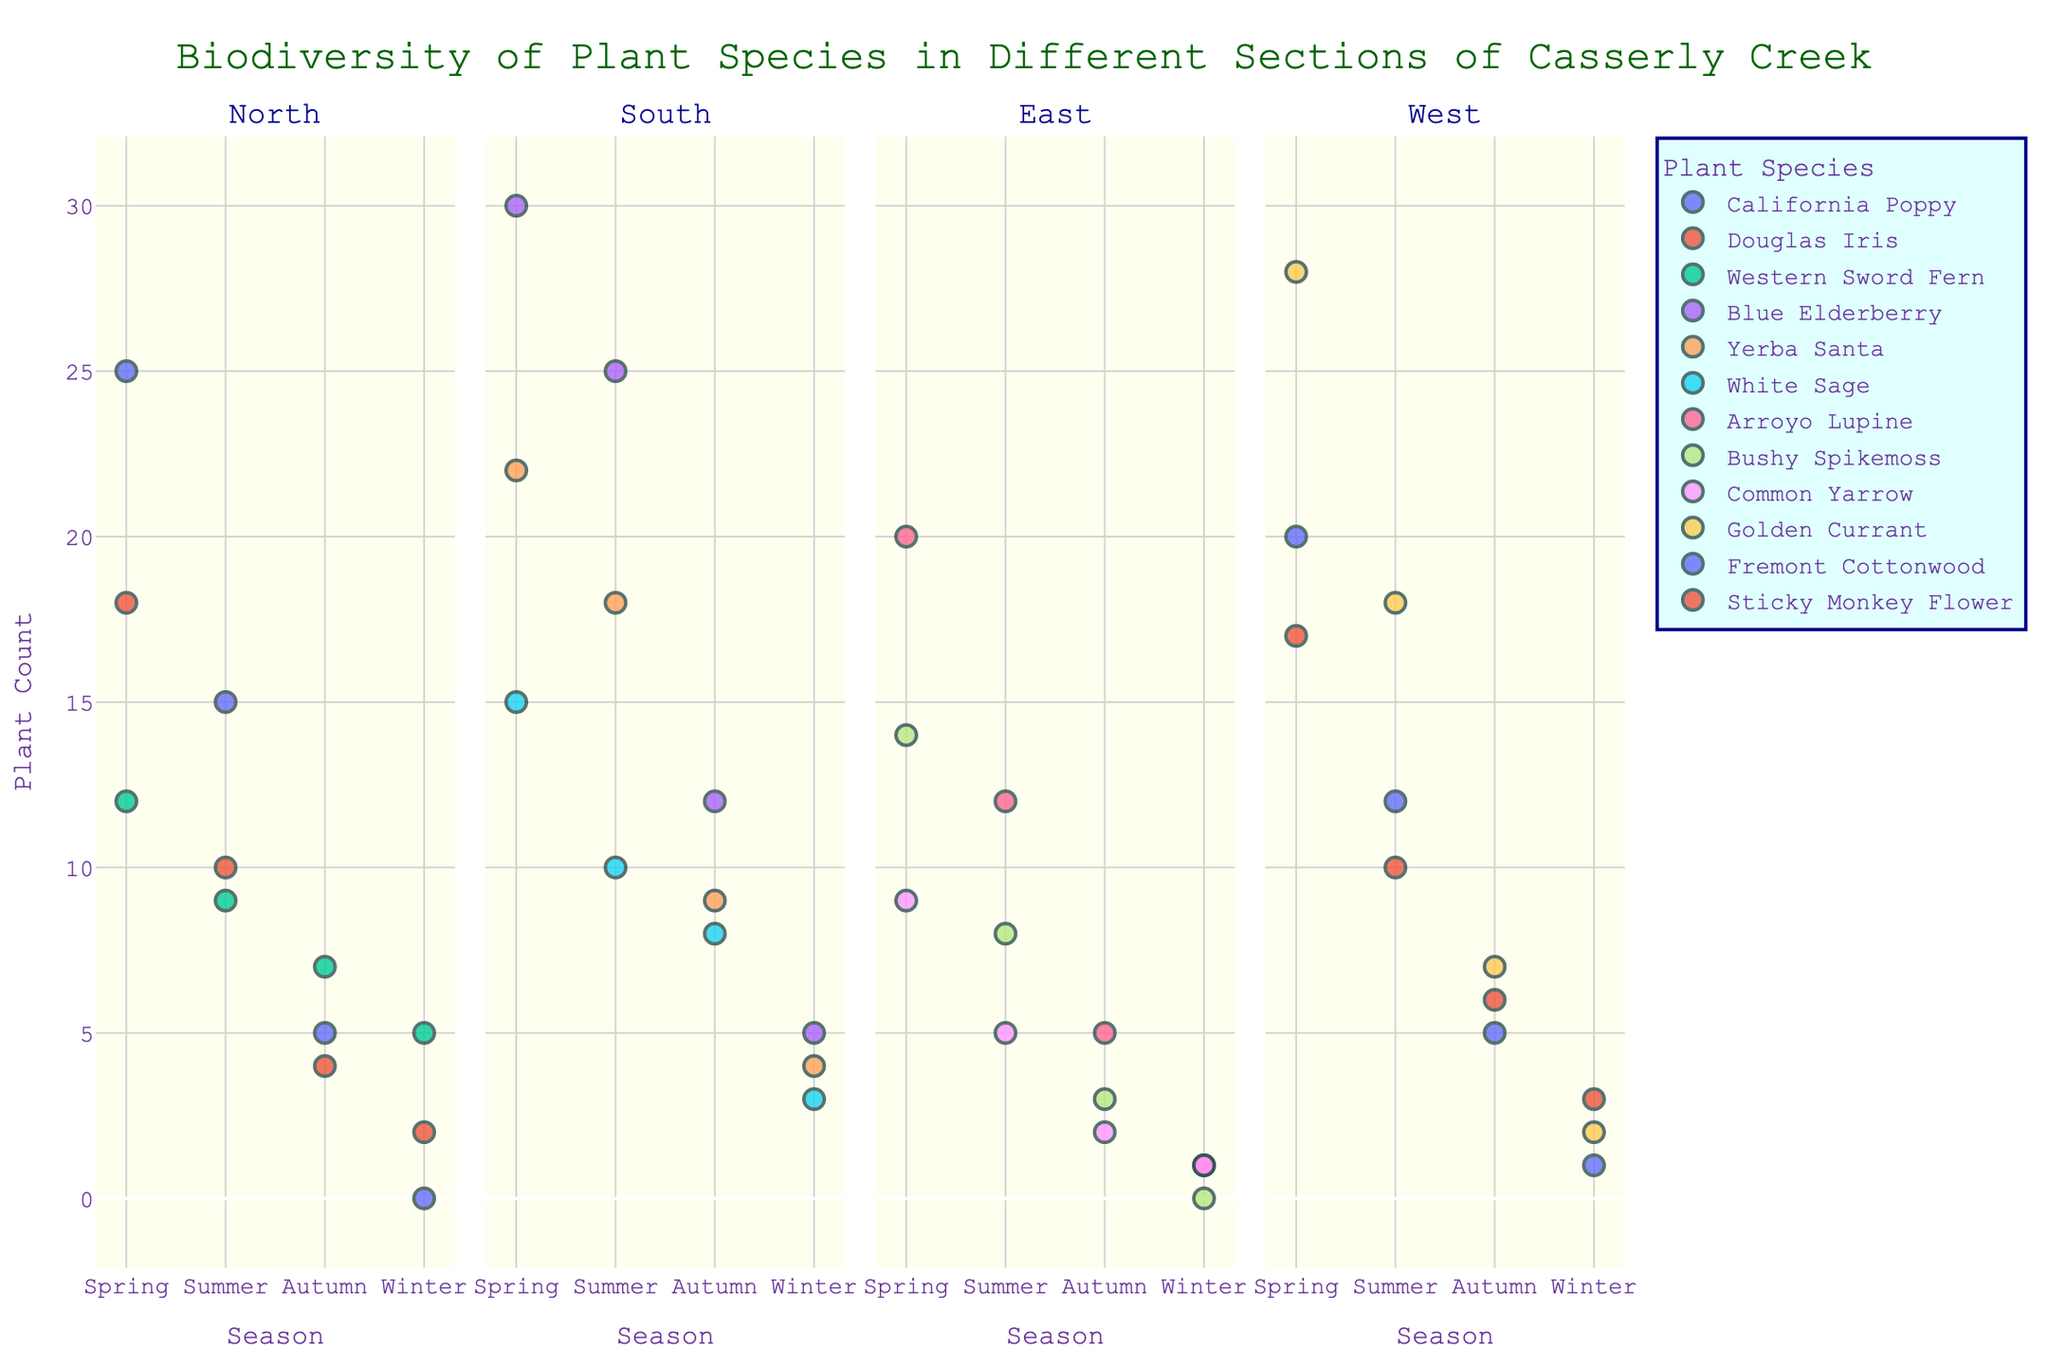How many sections are shown in the plot? The plot displays separate panels for each section, indicated at the top of each panel. By counting, we find the sections North, South, East, and West.
Answer: 4 How does the count of California Poppy change from Spring to Summer in the North section? Looking at the North section panel and comparing the data points for California Poppy in Spring (25) and Summer (15), the count decreases.
Answer: Decreases In which section and season is the count of Blue Elderberry the highest? Observing the South section across all seasons, we see that Blue Elderberry has the highest count in Spring with 30 plants.
Answer: South, Spring What is the total count of plant species in the East section during Autumn? Summing up the counts for Arroyo Lupine (5), Bushy Spikemoss (3), and Common Yarrow (2) in the East section during Autumn, we get 5 + 3 + 2.
Answer: 10 Which plant species has a non-zero count throughout all seasons in the South section? Checking the counts for each plant species in the South section across all seasons, we see that Blue Elderberry has non-zero counts (30, 25, 12, 5).
Answer: Blue Elderberry Compare the plant species diversity in Spring and Winter for the West section. Looking at the West section panel, Spring has three species (Golden Currant, Fremont Cottonwood, Sticky Monkey Flower) and Winter also has three species, but with lower counts.
Answer: Equal diversity Which plant species has the highest count in the West section during Spring and how much is it? In the West section during Spring, Golden Currant has the highest count with 28 plants.
Answer: Golden Currant, 28 Is there any plant species with a higher count in Winter than in Summer within any section? Comparing each section's Winter and Summer counts, only the Western Sword Fern in the North section shows this pattern with 5 in Winter and 9 in Summer.
Answer: No What is the average count of Douglas Iris in the North section across all seasons? Summing the counts of Douglas Iris in North (18 + 10 + 4 + 2) gives 34, and dividing by 4 seasons, the average is 34/4.
Answer: 8.5 